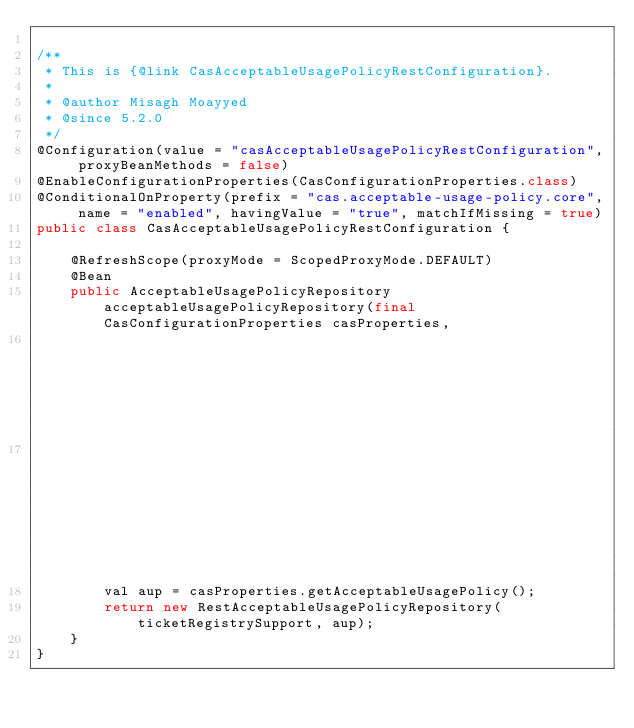Convert code to text. <code><loc_0><loc_0><loc_500><loc_500><_Java_>
/**
 * This is {@link CasAcceptableUsagePolicyRestConfiguration}.
 *
 * @author Misagh Moayyed
 * @since 5.2.0
 */
@Configuration(value = "casAcceptableUsagePolicyRestConfiguration", proxyBeanMethods = false)
@EnableConfigurationProperties(CasConfigurationProperties.class)
@ConditionalOnProperty(prefix = "cas.acceptable-usage-policy.core", name = "enabled", havingValue = "true", matchIfMissing = true)
public class CasAcceptableUsagePolicyRestConfiguration {

    @RefreshScope(proxyMode = ScopedProxyMode.DEFAULT)
    @Bean
    public AcceptableUsagePolicyRepository acceptableUsagePolicyRepository(final CasConfigurationProperties casProperties,
                                                                           @Qualifier(TicketRegistrySupport.BEAN_NAME)
                                                                           final TicketRegistrySupport ticketRegistrySupport) {
        val aup = casProperties.getAcceptableUsagePolicy();
        return new RestAcceptableUsagePolicyRepository(ticketRegistrySupport, aup);
    }
}
</code> 